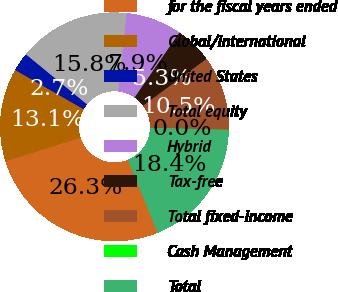Convert chart to OTSL. <chart><loc_0><loc_0><loc_500><loc_500><pie_chart><fcel>for the fiscal years ended<fcel>Global/international<fcel>United States<fcel>Total equity<fcel>Hybrid<fcel>Tax-free<fcel>Total fixed-income<fcel>Cash Management<fcel>Total<nl><fcel>26.28%<fcel>13.15%<fcel>2.65%<fcel>15.78%<fcel>7.9%<fcel>5.28%<fcel>10.53%<fcel>0.03%<fcel>18.4%<nl></chart> 